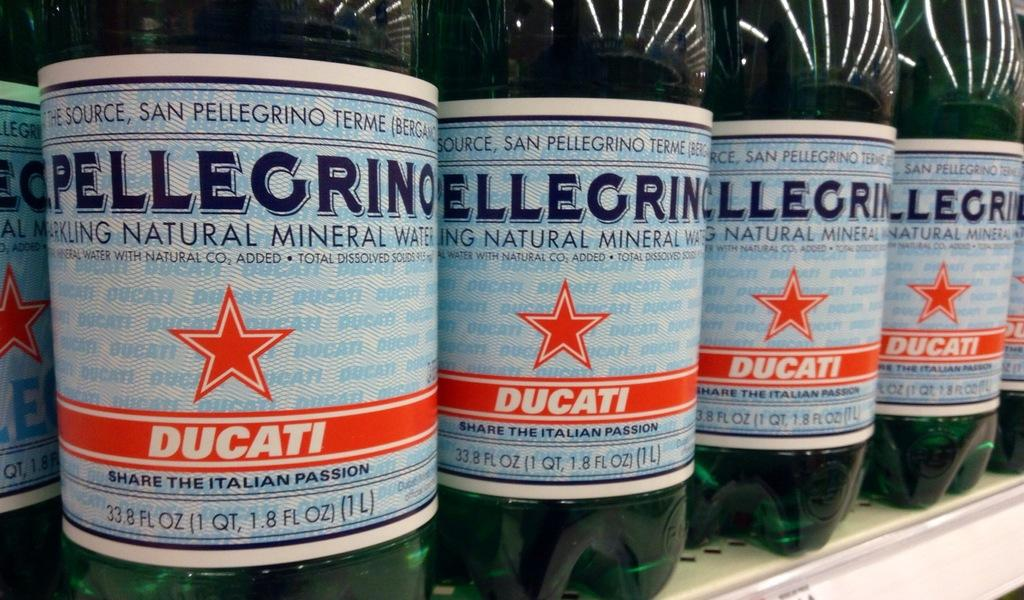<image>
Describe the image concisely. Many bottles of Pellegrino natural mineral water are stacked together on a shelf. 